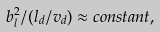<formula> <loc_0><loc_0><loc_500><loc_500>b _ { l } ^ { 2 } / ( l _ { d } / v _ { d } ) \approx c o n s t a n t ,</formula> 